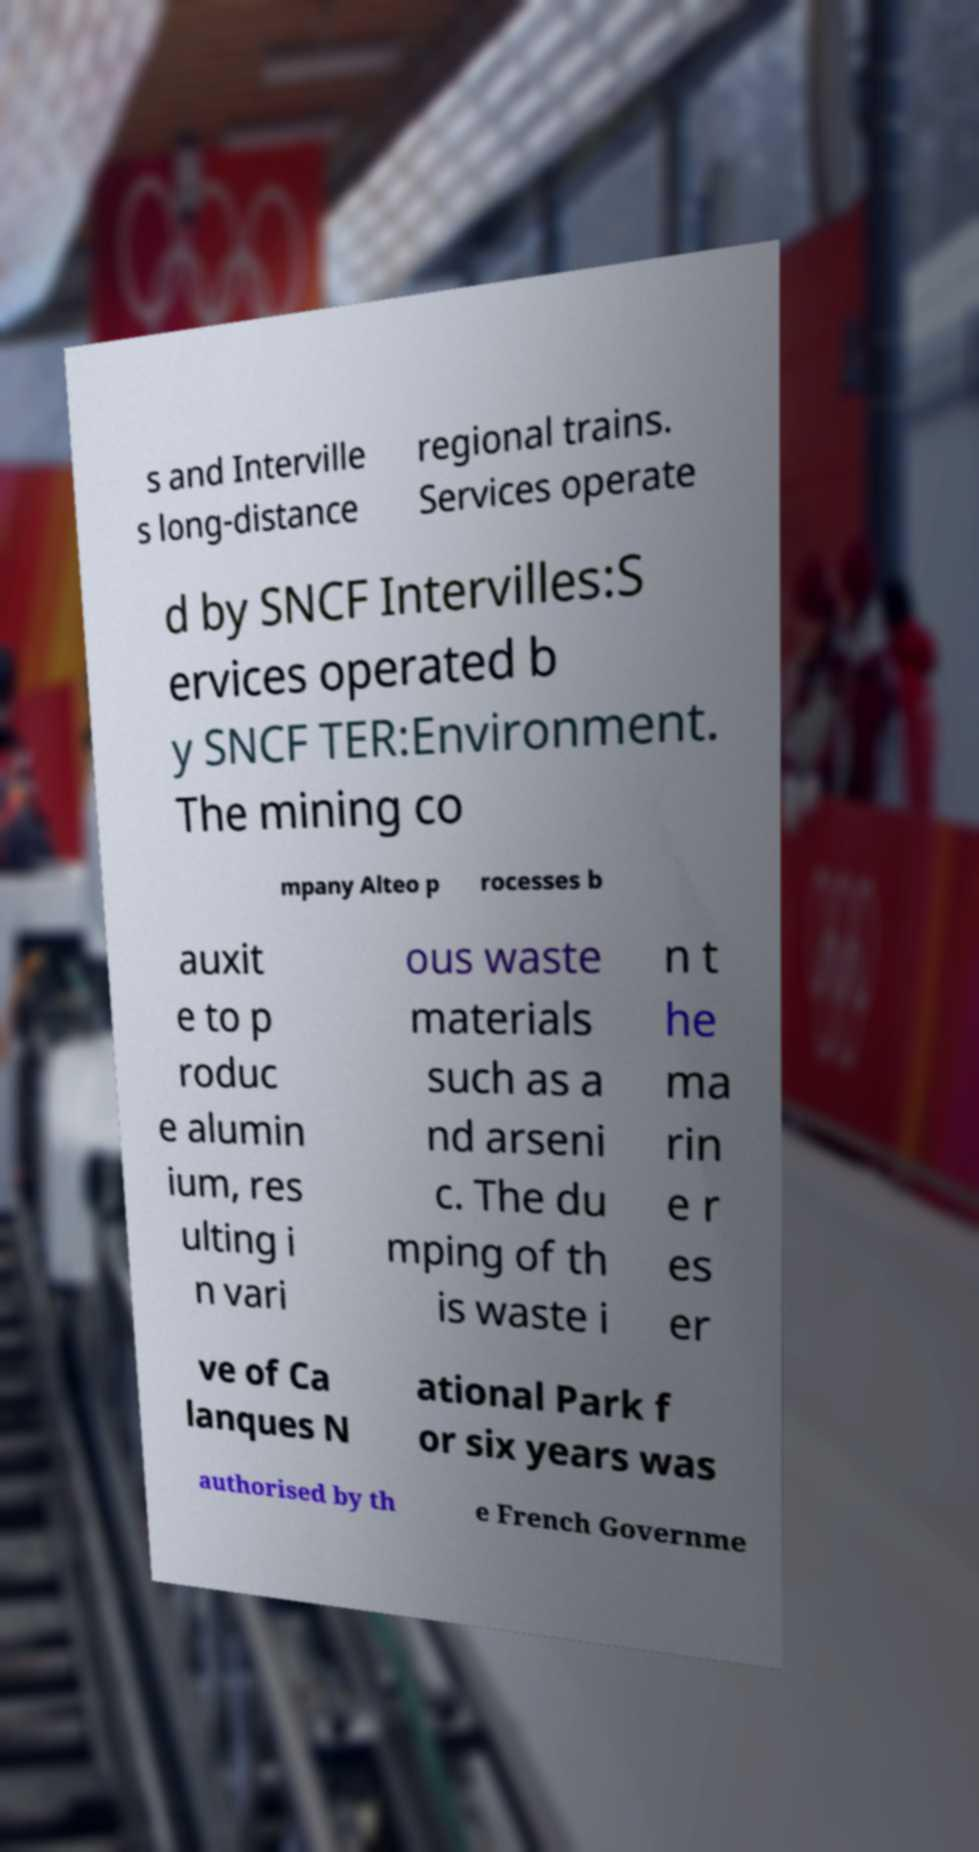For documentation purposes, I need the text within this image transcribed. Could you provide that? s and Interville s long-distance regional trains. Services operate d by SNCF Intervilles:S ervices operated b y SNCF TER:Environment. The mining co mpany Alteo p rocesses b auxit e to p roduc e alumin ium, res ulting i n vari ous waste materials such as a nd arseni c. The du mping of th is waste i n t he ma rin e r es er ve of Ca lanques N ational Park f or six years was authorised by th e French Governme 